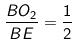Convert formula to latex. <formula><loc_0><loc_0><loc_500><loc_500>\frac { B O _ { 2 } } { B E } = \frac { 1 } { 2 }</formula> 